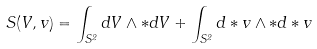Convert formula to latex. <formula><loc_0><loc_0><loc_500><loc_500>S ( V , v ) = \int _ { S ^ { 2 } } d V \wedge \ast d V + \int _ { S ^ { 2 } } d \ast v \wedge \ast d \ast v</formula> 